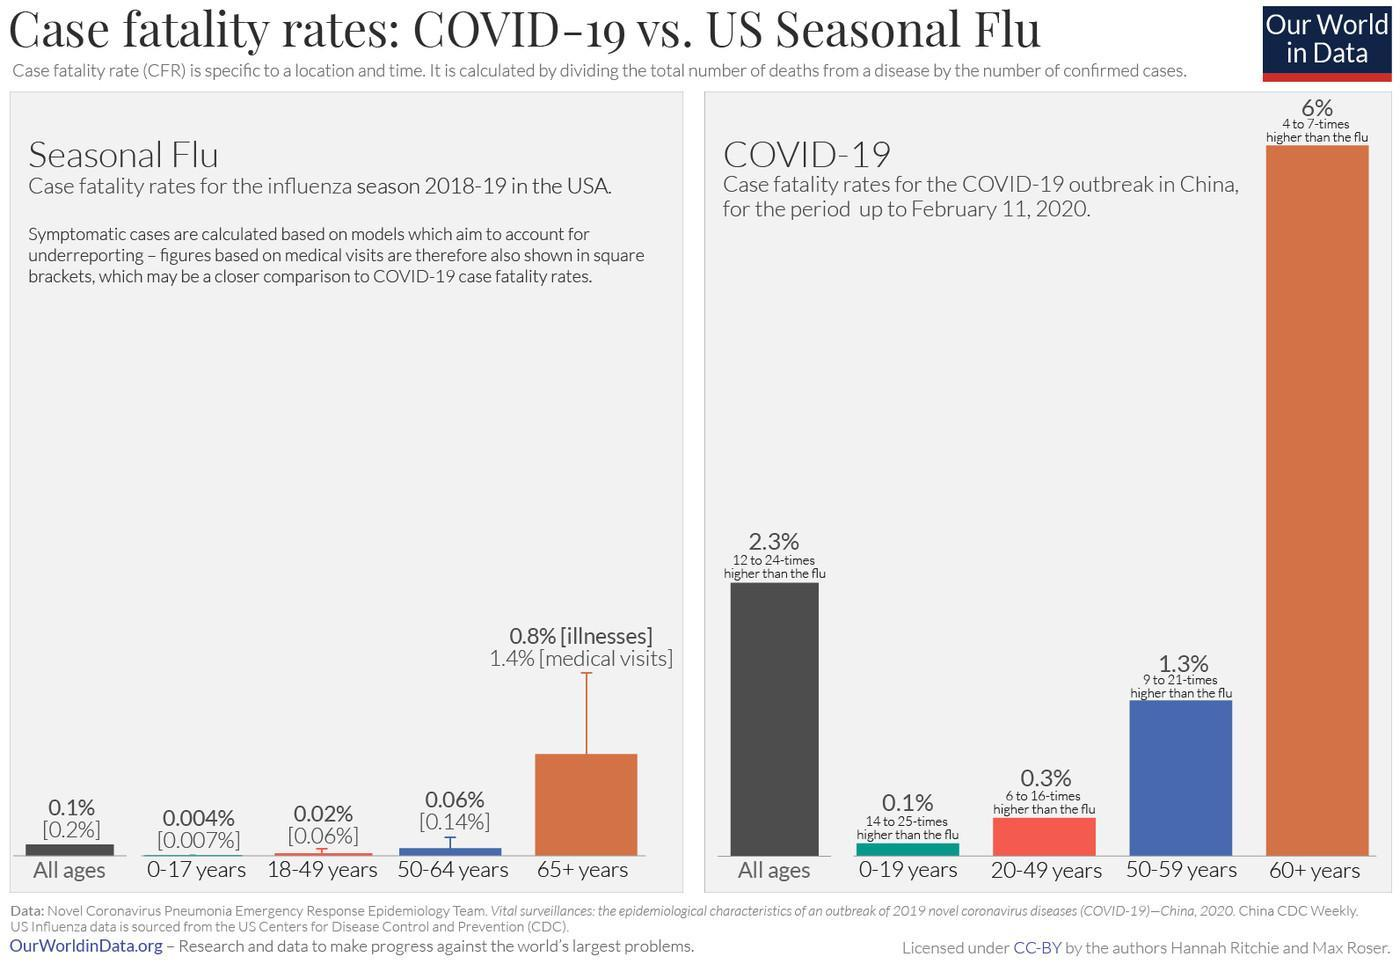What percent of senior citizens are affected by seasonal flu?
Answer the question with a short phrase. 0.8% 